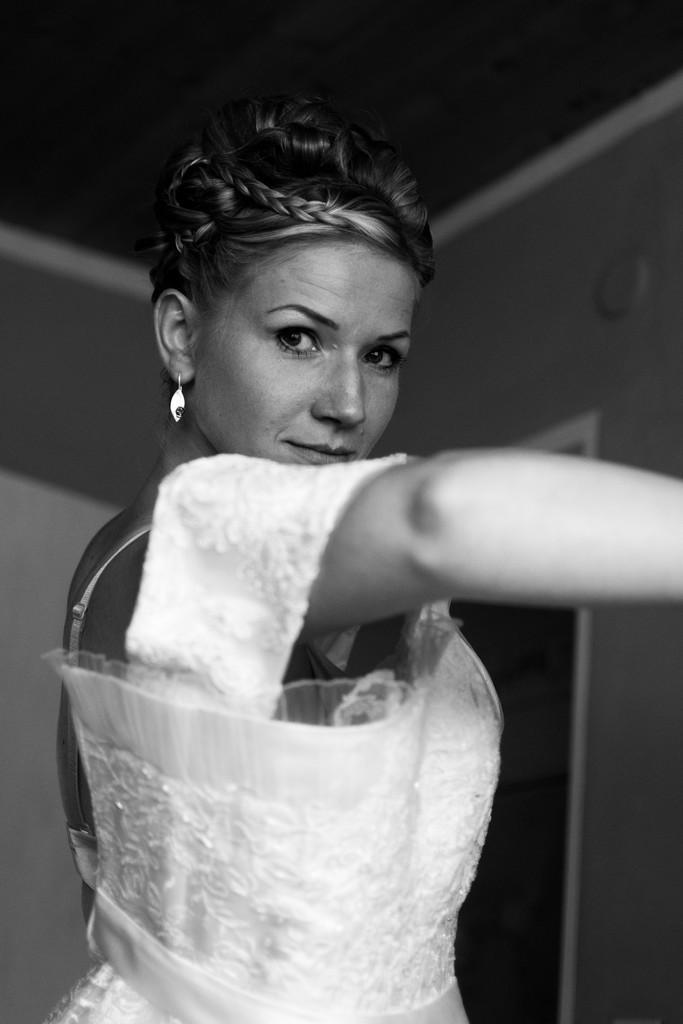Describe this image in one or two sentences. In this image I can see the black and white picture of a woman wearing white colored dress. In the background I can see the wall, the ceiling and the door. 